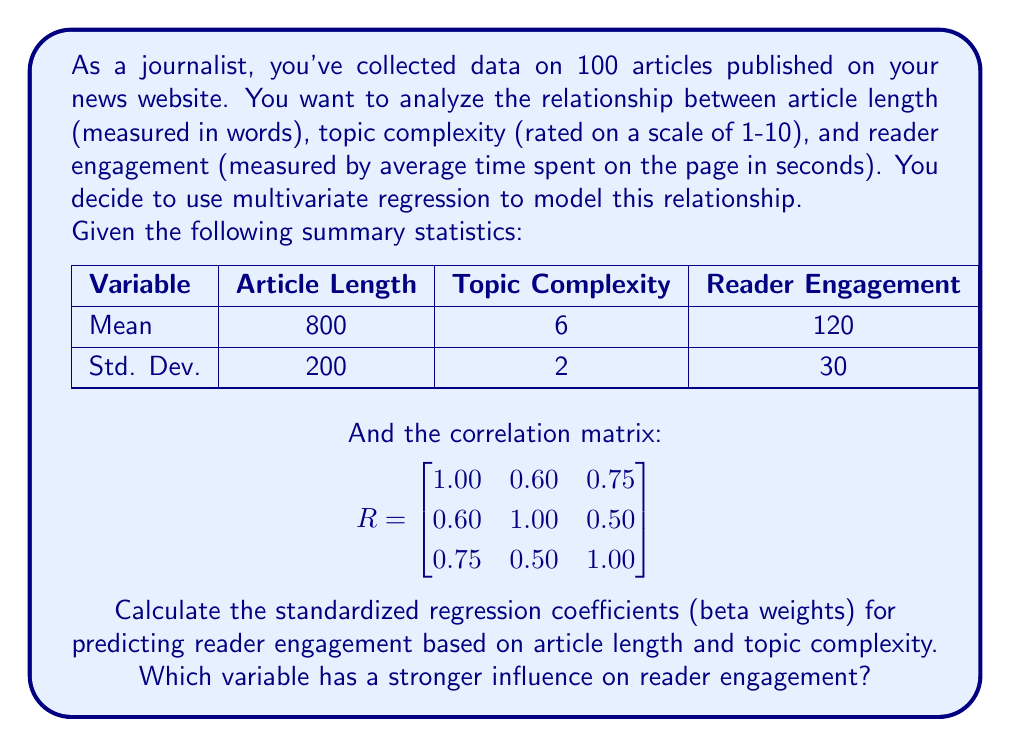Provide a solution to this math problem. To solve this problem, we'll follow these steps:

1) The standardized regression coefficients (beta weights) can be calculated using the formula:

   $$\beta = R_{xx}^{-1}R_{xy}$$

   Where $R_{xx}$ is the correlation matrix of the independent variables, and $R_{xy}$ is the vector of correlations between the independent variables and the dependent variable.

2) From the given correlation matrix, we can extract:

   $$R_{xx} = \begin{bmatrix}
   1.00 & 0.60 \\
   0.60 & 1.00
   \end{bmatrix}$$

   $$R_{xy} = \begin{bmatrix}
   0.75 \\
   0.50
   \end{bmatrix}$$

3) We need to calculate $R_{xx}^{-1}$. For a 2x2 matrix, the inverse is:

   $$R_{xx}^{-1} = \frac{1}{1-0.60^2}\begin{bmatrix}
   1.00 & -0.60 \\
   -0.60 & 1.00
   \end{bmatrix} = \begin{bmatrix}
   1.5625 & -0.9375 \\
   -0.9375 & 1.5625
   \end{bmatrix}$$

4) Now we can calculate $\beta$:

   $$\beta = \begin{bmatrix}
   1.5625 & -0.9375 \\
   -0.9375 & 1.5625
   \end{bmatrix} \begin{bmatrix}
   0.75 \\
   0.50
   \end{bmatrix}$$

5) Multiplying these matrices:

   $$\beta = \begin{bmatrix}
   (1.5625 * 0.75) + (-0.9375 * 0.50) \\
   (-0.9375 * 0.75) + (1.5625 * 0.50)
   \end{bmatrix} = \begin{bmatrix}
   0.703125 \\
   0.078125
   \end{bmatrix}$$

6) Therefore, the standardized regression coefficient for article length is approximately 0.703, and for topic complexity is approximately 0.078.

7) The variable with the larger absolute beta weight has a stronger influence on the dependent variable. In this case, article length (0.703) has a stronger influence on reader engagement compared to topic complexity (0.078).
Answer: Article length (β ≈ 0.703) has a stronger influence on reader engagement than topic complexity (β ≈ 0.078). 